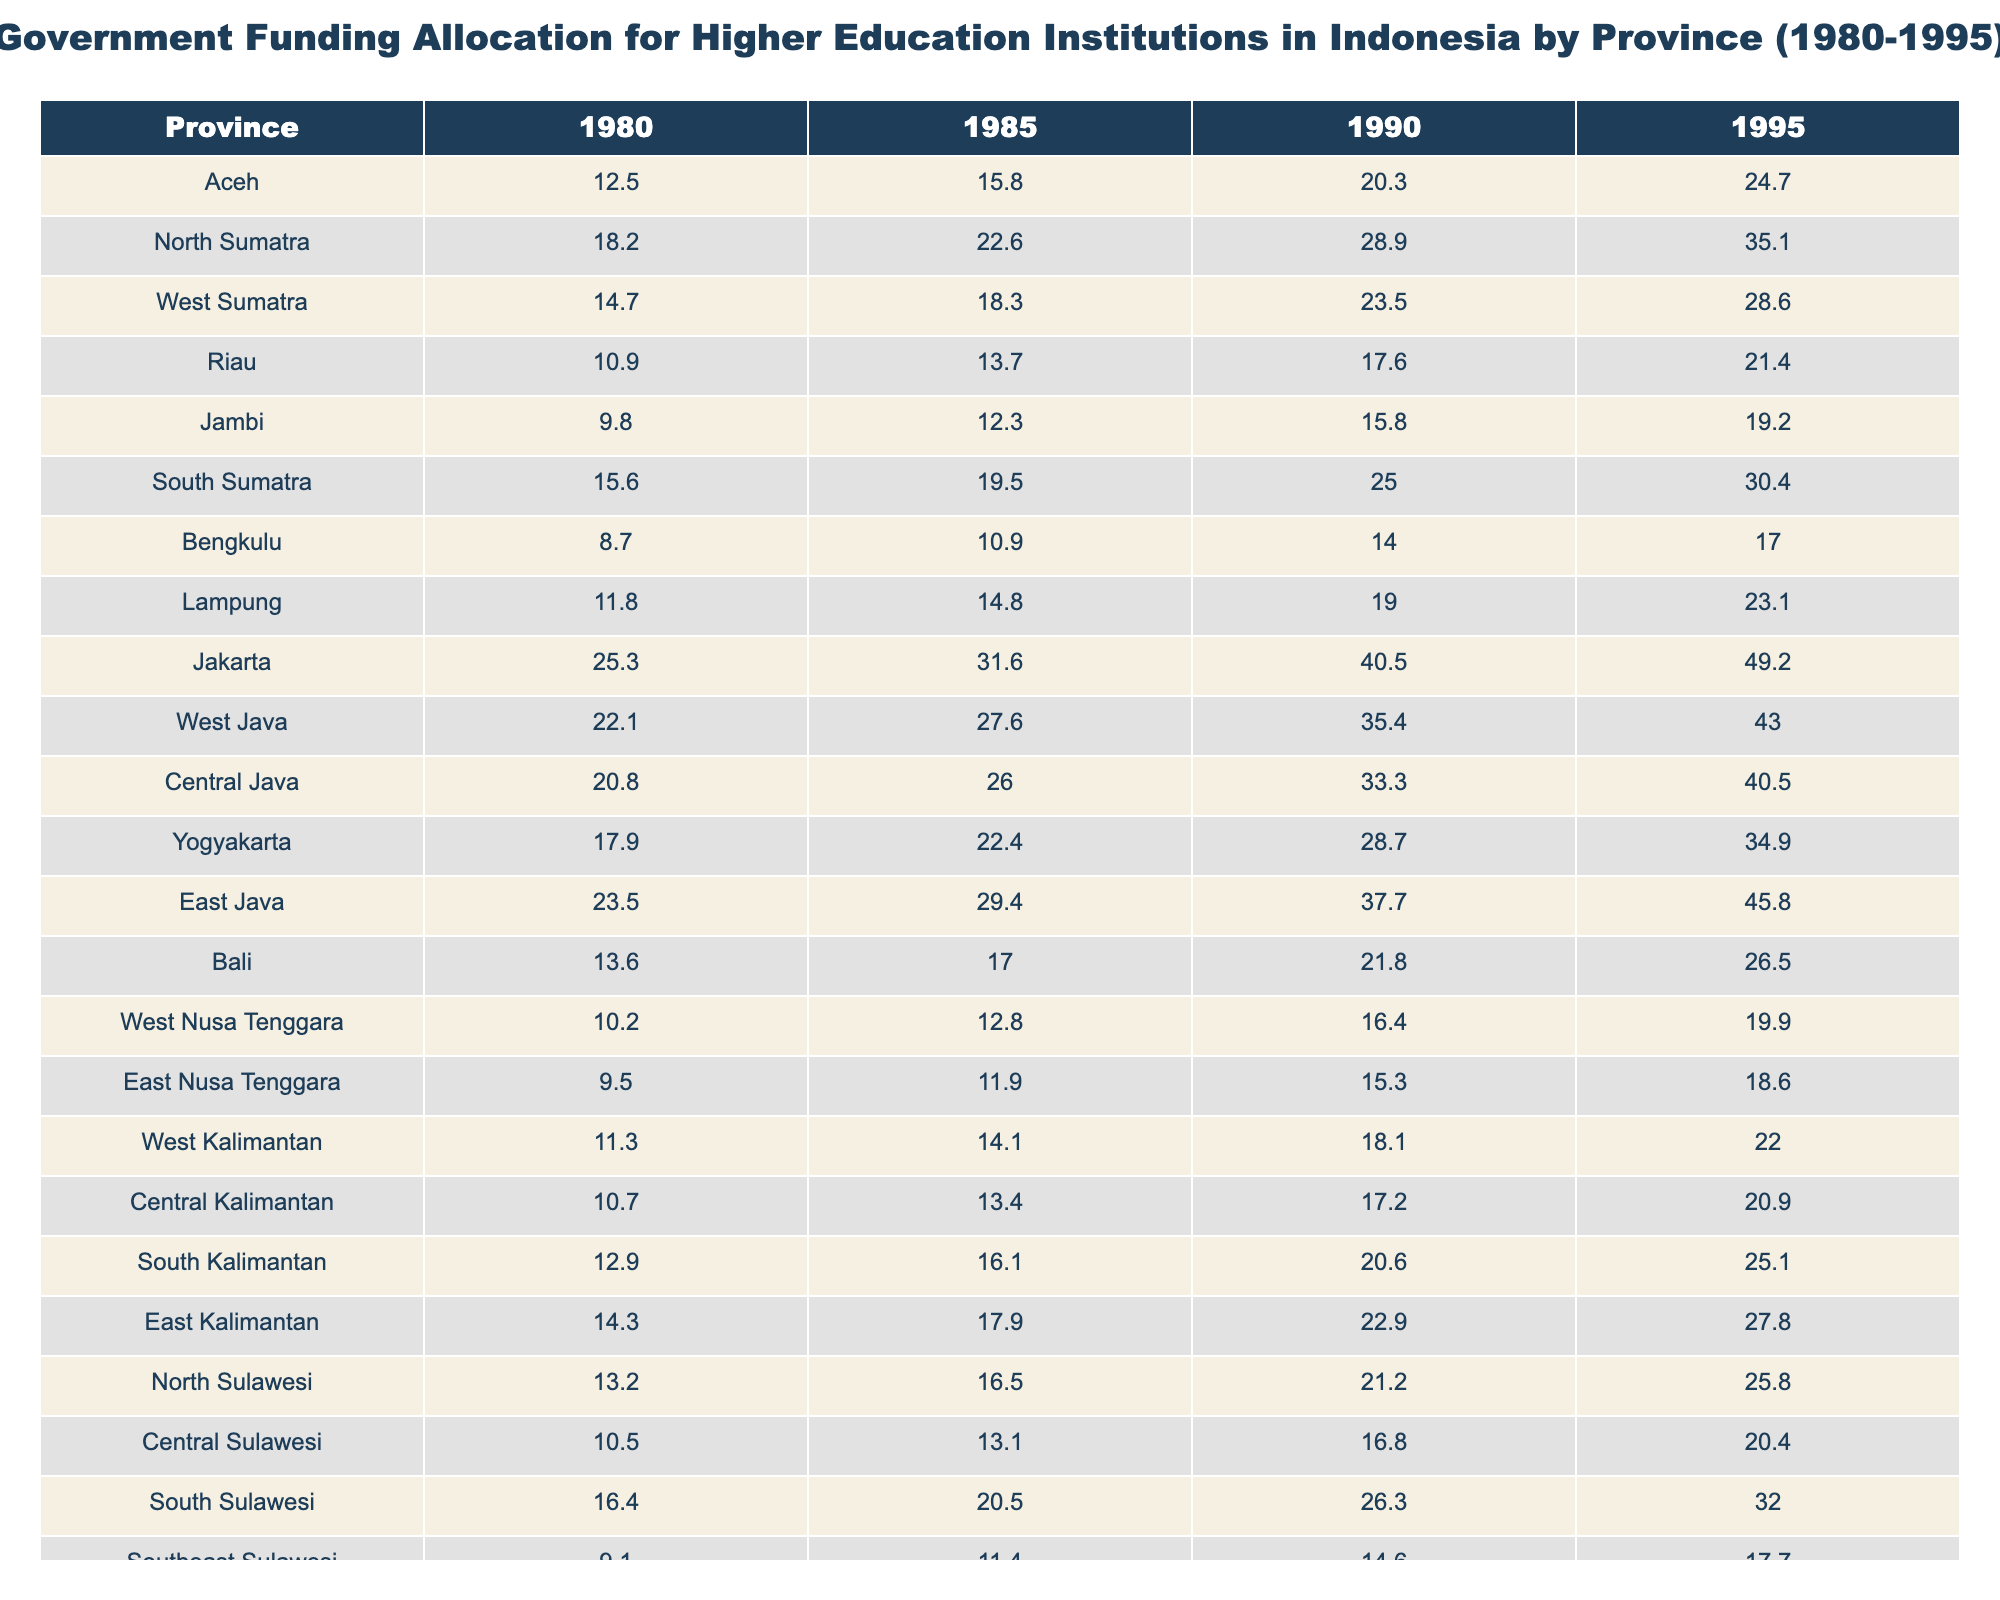What was the government funding allocation for Jakarta in 1990? In the table, the value for Jakarta in the year 1990 is listed directly. This value can be found in the row corresponding to Jakarta and the column for 1990.
Answer: 40.5 Which province had the highest funding allocation in 1985? To find the highest allocation in 1985, look at all the values in the 1985 column, comparing them. Jakarta has the highest value of 31.6.
Answer: Jakarta What was the difference in funding for North Sumatra from 1980 to 1995? First, locate the values for North Sumatra in 1980 (18.2) and 1995 (35.1). The difference can be calculated by subtracting the 1980 value from the 1995 value: 35.1 - 18.2 = 16.9.
Answer: 16.9 What was the average funding allocation for Bali from 1980 to 1995? To find the average for Bali, sum the values for the years 1980 (13.6), 1985 (17.0), 1990 (21.8), and 1995 (26.5): 13.6 + 17.0 + 21.8 + 26.5 = 78.9. Then divide the sum by the number of years (4): 78.9 / 4 = 19.725.
Answer: 19.725 Which province had the largest increase in funding allocation from 1980 to 1995? Evaluate the increase for each province by subtracting the 1980 value from the 1995 value for all provinces. The increase for West Java is the largest at 20.9 (43.0 - 22.1).
Answer: West Java Did East Nusa Tenggara's funding allocation increase every year from 1980 to 1995? Check the values for East Nusa Tenggara for each year. The values are 9.5, 11.9, 15.3, and 18.6, which shows a consistent increase year over year.
Answer: Yes How much total funding was allocated to Central Java from 1980 to 1995? Add the values for Central Java: 20.8 (1980) + 26.0 (1985) + 33.3 (1990) + 40.5 (1995) = 120.6.
Answer: 120.6 Which year had the lowest government funding allocation for Papua? Review the values for Papua: 12.1 (1980), 15.1 (1985), 19.4 (1990), and 23.6 (1995) to identify the lowest value, which occurs in 1980.
Answer: 1980 If you combine the funding allocations for all provinces in 1995, what is the total? Sum all the individual row values for the year 1995: (24.7 + 35.1 + 28.6 + 21.4 + 19.2 + 30.4 + 17.0 + 23.1 + 49.2 + 43.0 + 40.5 + 34.9 + 45.8 + 26.5 + 19.9 + 18.6 + 22.0 + 20.9 + 25.1 + 27.8 + 25.8 + 20.4 + 32.0 + 17.7 + 22.6 + 23.6) = 718.6.
Answer: 718.6 What trend do you observe in the funding allocation for higher education institutions between 1980 and 1995? By examining the values across the years, you can see that funding allocations generally increased in most provinces from 1980 to 1995, indicating a positive trend in government support for higher education over that period.
Answer: Increasing trend 